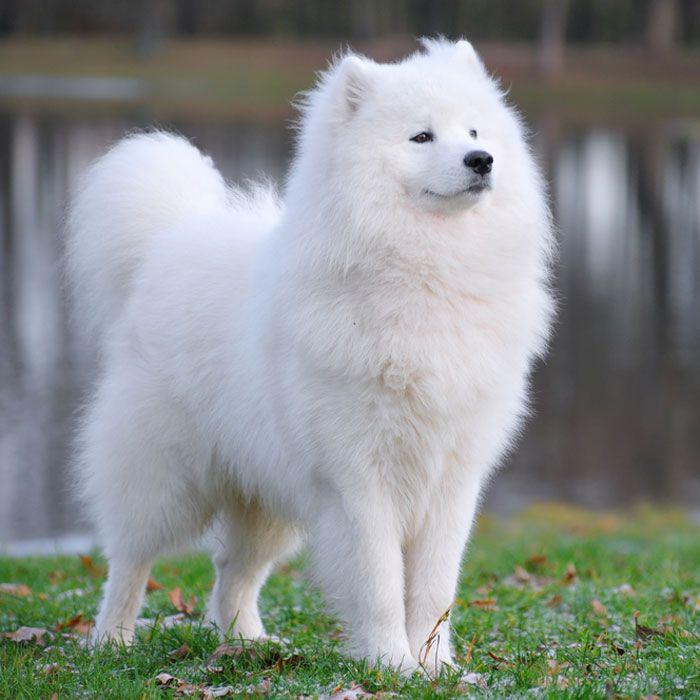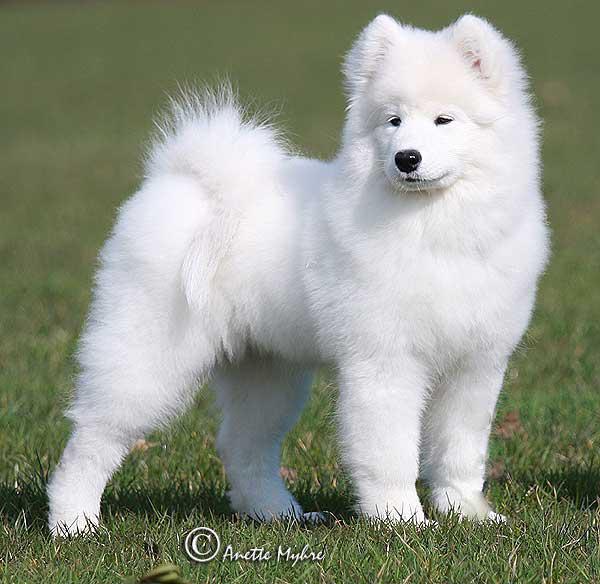The first image is the image on the left, the second image is the image on the right. Assess this claim about the two images: "An image shows a white dog posed indoors in a white room.". Correct or not? Answer yes or no. No. The first image is the image on the left, the second image is the image on the right. Evaluate the accuracy of this statement regarding the images: "At least one of the dogs is standing outside.". Is it true? Answer yes or no. Yes. 